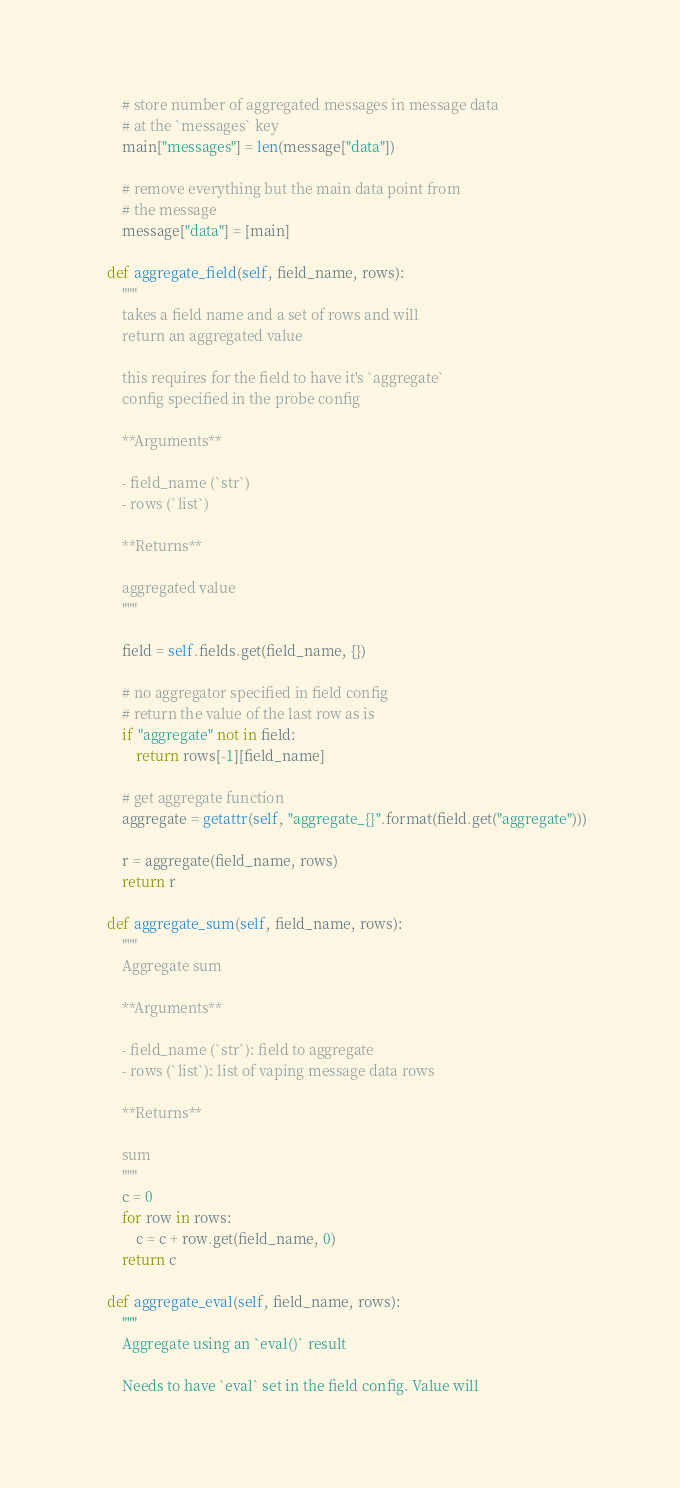Convert code to text. <code><loc_0><loc_0><loc_500><loc_500><_Python_>
        # store number of aggregated messages in message data
        # at the `messages` key
        main["messages"] = len(message["data"])

        # remove everything but the main data point from
        # the message
        message["data"] = [main]

    def aggregate_field(self, field_name, rows):
        """
        takes a field name and a set of rows and will
        return an aggregated value

        this requires for the field to have it's `aggregate`
        config specified in the probe config

        **Arguments**

        - field_name (`str`)
        - rows (`list`)

        **Returns**

        aggregated value
        """

        field = self.fields.get(field_name, {})

        # no aggregator specified in field config
        # return the value of the last row as is
        if "aggregate" not in field:
            return rows[-1][field_name]

        # get aggregate function
        aggregate = getattr(self, "aggregate_{}".format(field.get("aggregate")))

        r = aggregate(field_name, rows)
        return r

    def aggregate_sum(self, field_name, rows):
        """
        Aggregate sum

        **Arguments**

        - field_name (`str`): field to aggregate
        - rows (`list`): list of vaping message data rows

        **Returns**

        sum
        """
        c = 0
        for row in rows:
            c = c + row.get(field_name, 0)
        return c

    def aggregate_eval(self, field_name, rows):
        """
        Aggregate using an `eval()` result

        Needs to have `eval` set in the field config. Value will</code> 